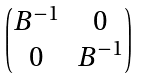<formula> <loc_0><loc_0><loc_500><loc_500>\begin{pmatrix} B ^ { - 1 } & 0 \\ 0 & B ^ { - 1 } \end{pmatrix}</formula> 